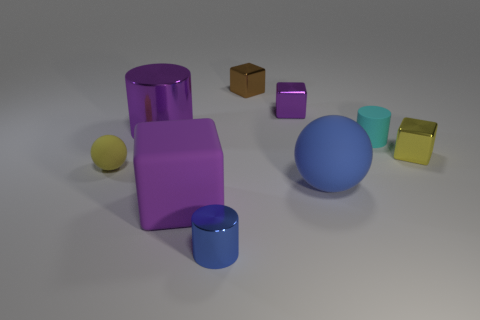How many purple blocks must be subtracted to get 1 purple blocks? 1 Subtract all cylinders. How many objects are left? 6 Add 7 big matte objects. How many big matte objects exist? 9 Subtract 0 cyan spheres. How many objects are left? 9 Subtract all yellow rubber balls. Subtract all large rubber balls. How many objects are left? 7 Add 1 tiny yellow objects. How many tiny yellow objects are left? 3 